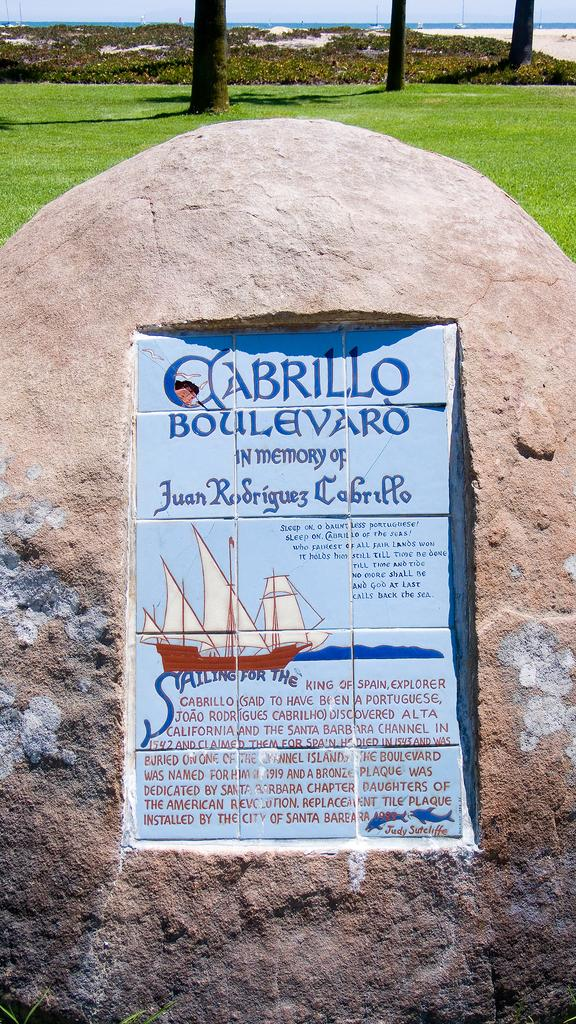What type of stone is present in the image? There is lay stone in the image. What type of vegetation can be seen in the image? There is grass and trees visible in the image. What natural element is visible in the image? There is water visible in the image. What part of the natural environment is visible in the image? The sky is visible in the image. What is the chance of observing a limit in the image? There is no reference to a chance, observation, or limit in the image; it features lay stone, grass, trees, water, and the sky. 